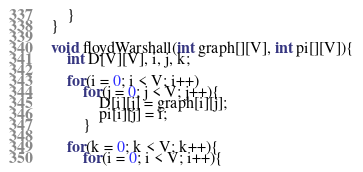Convert code to text. <code><loc_0><loc_0><loc_500><loc_500><_C++_>    }
}

void floydWarshall(int graph[][V], int pi[][V]){
    int D[V][V], i, j, k;

    for(i = 0; i < V; i++)
        for(j = 0; j < V; j++){
            D[i][j] = graph[i][j];
            pi[i][j] = i;
        }

    for(k = 0; k < V; k++){
        for(i = 0; i < V; i++){</code> 